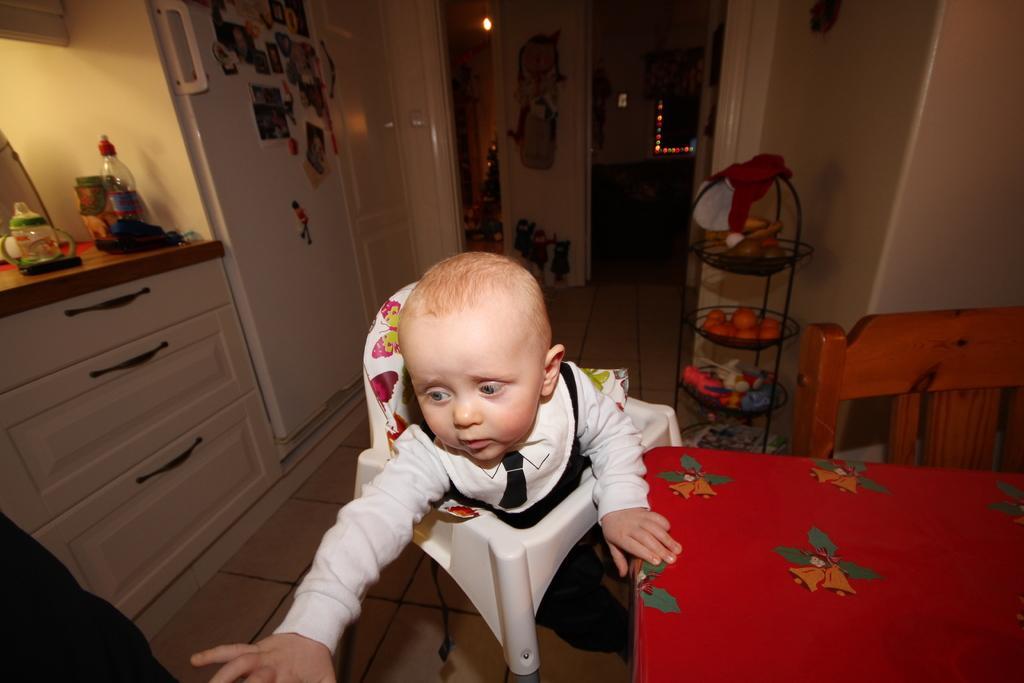Can you describe this image briefly? This picture is clicked inside the room. Here, we see a baby in white t-shirt is sitting on chair. In front of her, we see a bed which is covered with red color bed sheet. Behind her, we see a white door and a stand on which fruits and toys are placed. On left corner of the picture, we see a counter top on which water bottle and clothes are placed and beside that, we see refrigerator. 